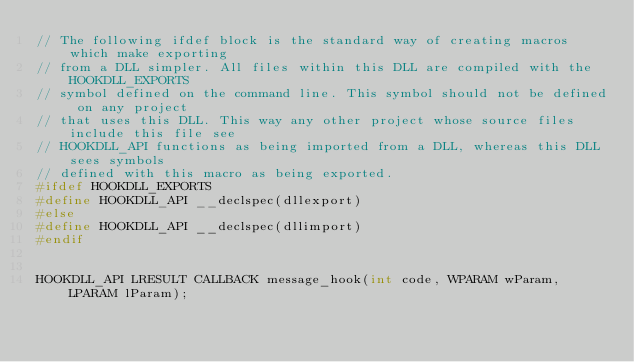<code> <loc_0><loc_0><loc_500><loc_500><_C_>// The following ifdef block is the standard way of creating macros which make exporting
// from a DLL simpler. All files within this DLL are compiled with the HOOKDLL_EXPORTS
// symbol defined on the command line. This symbol should not be defined on any project
// that uses this DLL. This way any other project whose source files include this file see
// HOOKDLL_API functions as being imported from a DLL, whereas this DLL sees symbols
// defined with this macro as being exported.
#ifdef HOOKDLL_EXPORTS
#define HOOKDLL_API __declspec(dllexport)
#else
#define HOOKDLL_API __declspec(dllimport)
#endif


HOOKDLL_API LRESULT CALLBACK message_hook(int code, WPARAM wParam, LPARAM lParam);
</code> 